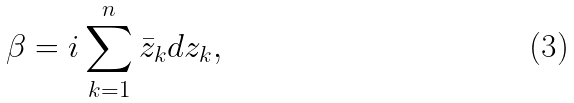<formula> <loc_0><loc_0><loc_500><loc_500>\beta = i \sum _ { k = 1 } ^ { n } \bar { z } _ { k } d z _ { k } ,</formula> 